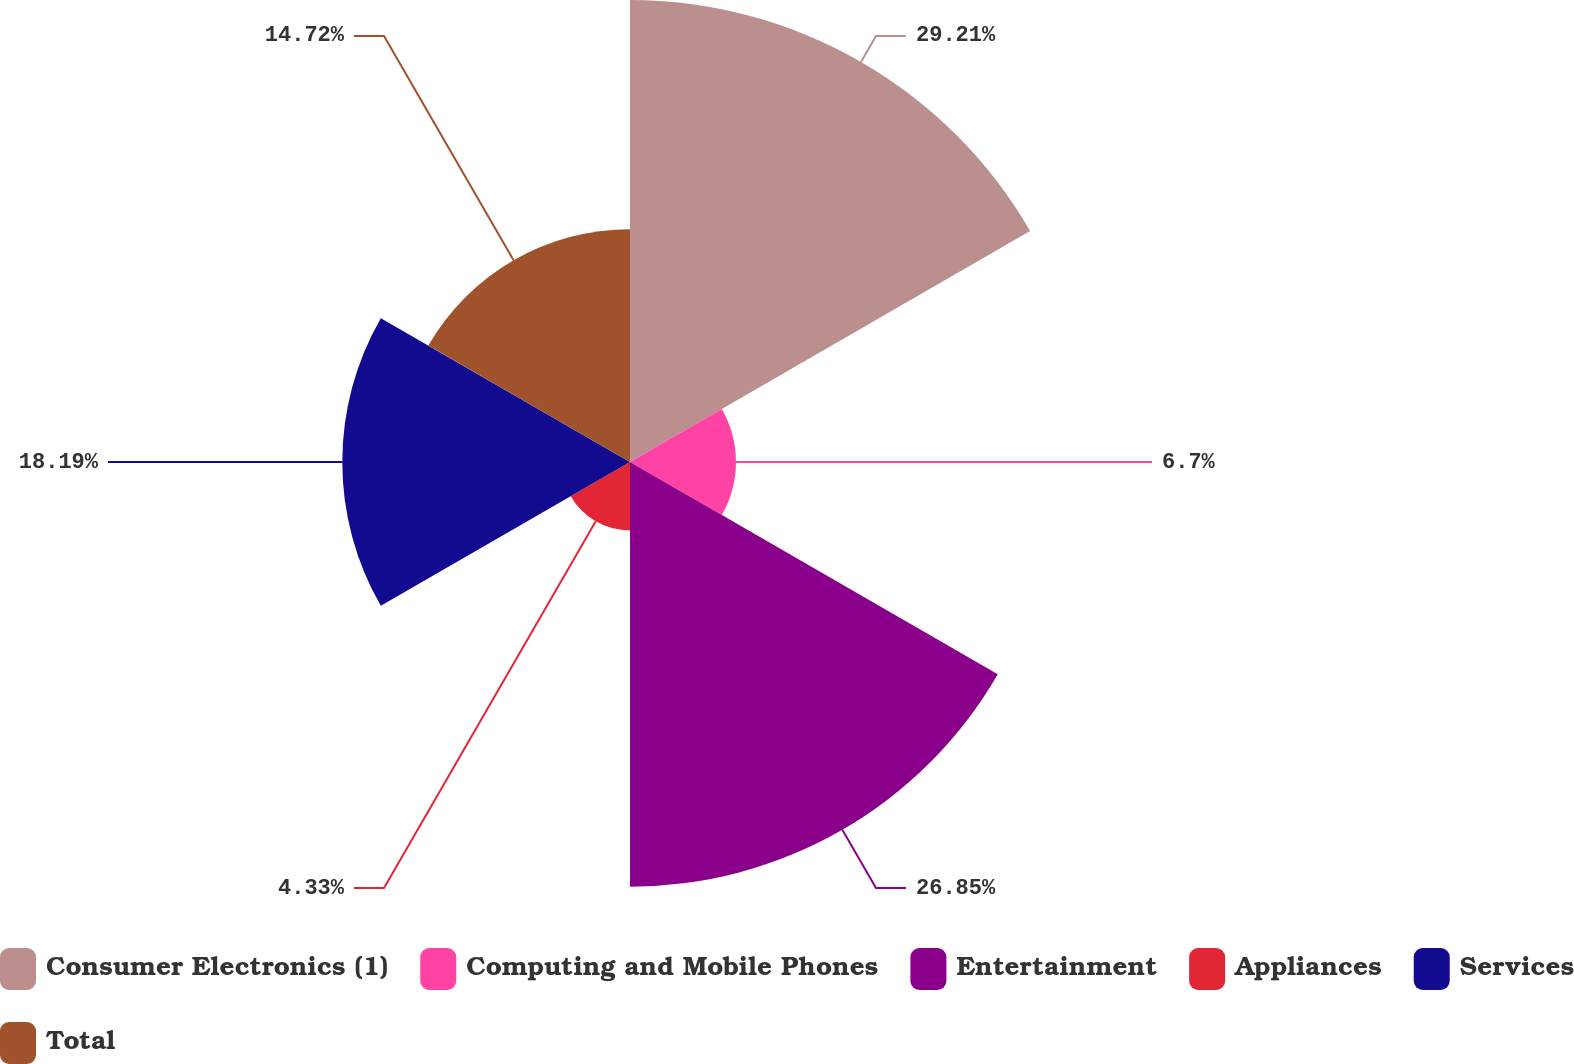<chart> <loc_0><loc_0><loc_500><loc_500><pie_chart><fcel>Consumer Electronics (1)<fcel>Computing and Mobile Phones<fcel>Entertainment<fcel>Appliances<fcel>Services<fcel>Total<nl><fcel>29.21%<fcel>6.7%<fcel>26.85%<fcel>4.33%<fcel>18.19%<fcel>14.72%<nl></chart> 